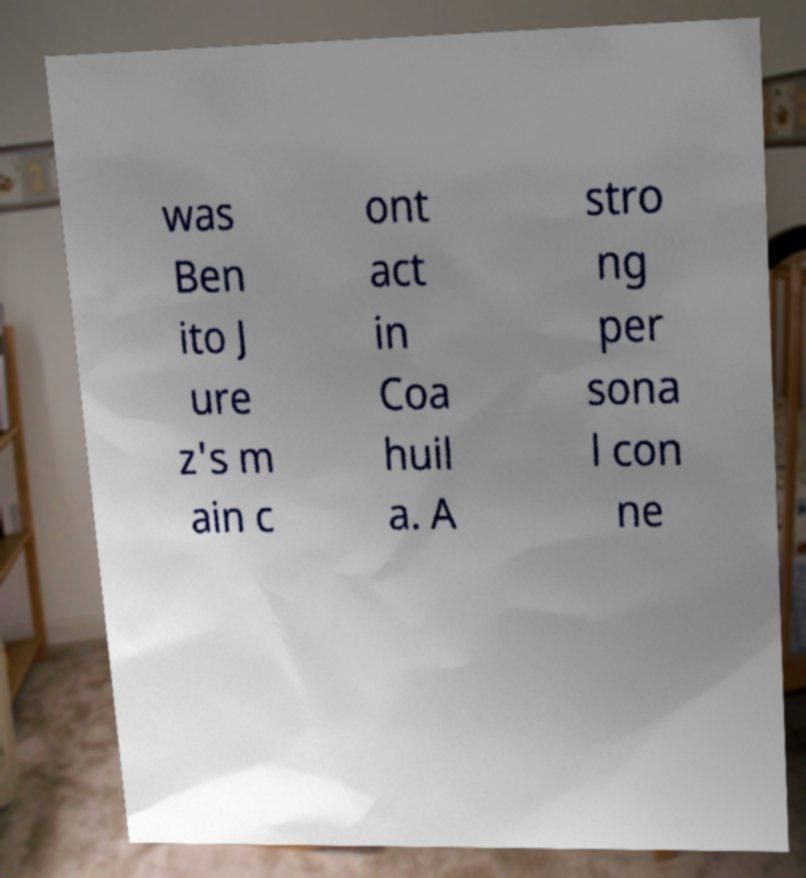Please read and relay the text visible in this image. What does it say? was Ben ito J ure z's m ain c ont act in Coa huil a. A stro ng per sona l con ne 